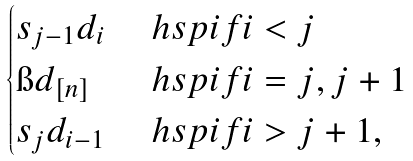Convert formula to latex. <formula><loc_0><loc_0><loc_500><loc_500>\begin{cases} s _ { j - 1 } d _ { i } & \ h s p { i f } i < j \\ \i d _ { [ n ] } & \ h s p { i f } i = j , j + 1 \\ s _ { j } d _ { i - 1 } & \ h s p { i f } i > j + 1 , \end{cases}</formula> 